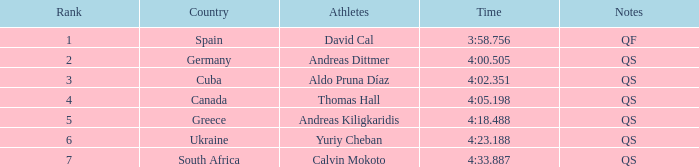What are the notes for the athlete from South Africa? QS. 